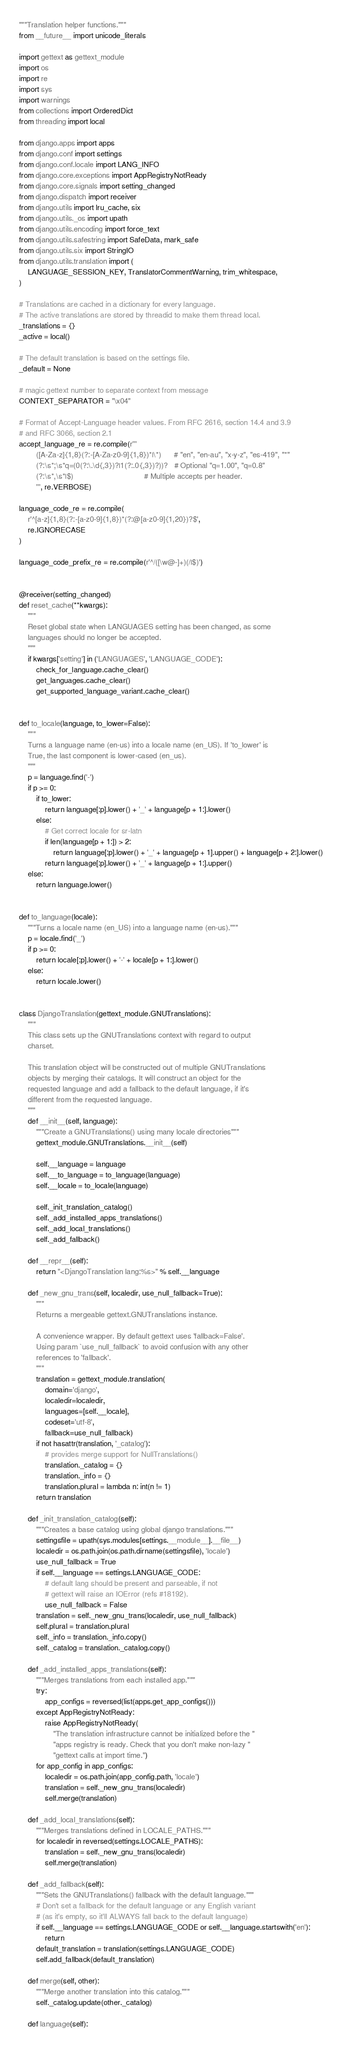Convert code to text. <code><loc_0><loc_0><loc_500><loc_500><_Python_>"""Translation helper functions."""
from __future__ import unicode_literals

import gettext as gettext_module
import os
import re
import sys
import warnings
from collections import OrderedDict
from threading import local

from django.apps import apps
from django.conf import settings
from django.conf.locale import LANG_INFO
from django.core.exceptions import AppRegistryNotReady
from django.core.signals import setting_changed
from django.dispatch import receiver
from django.utils import lru_cache, six
from django.utils._os import upath
from django.utils.encoding import force_text
from django.utils.safestring import SafeData, mark_safe
from django.utils.six import StringIO
from django.utils.translation import (
    LANGUAGE_SESSION_KEY, TranslatorCommentWarning, trim_whitespace,
)

# Translations are cached in a dictionary for every language.
# The active translations are stored by threadid to make them thread local.
_translations = {}
_active = local()

# The default translation is based on the settings file.
_default = None

# magic gettext number to separate context from message
CONTEXT_SEPARATOR = "\x04"

# Format of Accept-Language header values. From RFC 2616, section 14.4 and 3.9
# and RFC 3066, section 2.1
accept_language_re = re.compile(r'''
        ([A-Za-z]{1,8}(?:-[A-Za-z0-9]{1,8})*|\*)      # "en", "en-au", "x-y-z", "es-419", "*"
        (?:\s*;\s*q=(0(?:\.\d{,3})?|1(?:.0{,3})?))?   # Optional "q=1.00", "q=0.8"
        (?:\s*,\s*|$)                                 # Multiple accepts per header.
        ''', re.VERBOSE)

language_code_re = re.compile(
    r'^[a-z]{1,8}(?:-[a-z0-9]{1,8})*(?:@[a-z0-9]{1,20})?$',
    re.IGNORECASE
)

language_code_prefix_re = re.compile(r'^/([\w@-]+)(/|$)')


@receiver(setting_changed)
def reset_cache(**kwargs):
    """
    Reset global state when LANGUAGES setting has been changed, as some
    languages should no longer be accepted.
    """
    if kwargs['setting'] in ('LANGUAGES', 'LANGUAGE_CODE'):
        check_for_language.cache_clear()
        get_languages.cache_clear()
        get_supported_language_variant.cache_clear()


def to_locale(language, to_lower=False):
    """
    Turns a language name (en-us) into a locale name (en_US). If 'to_lower' is
    True, the last component is lower-cased (en_us).
    """
    p = language.find('-')
    if p >= 0:
        if to_lower:
            return language[:p].lower() + '_' + language[p + 1:].lower()
        else:
            # Get correct locale for sr-latn
            if len(language[p + 1:]) > 2:
                return language[:p].lower() + '_' + language[p + 1].upper() + language[p + 2:].lower()
            return language[:p].lower() + '_' + language[p + 1:].upper()
    else:
        return language.lower()


def to_language(locale):
    """Turns a locale name (en_US) into a language name (en-us)."""
    p = locale.find('_')
    if p >= 0:
        return locale[:p].lower() + '-' + locale[p + 1:].lower()
    else:
        return locale.lower()


class DjangoTranslation(gettext_module.GNUTranslations):
    """
    This class sets up the GNUTranslations context with regard to output
    charset.

    This translation object will be constructed out of multiple GNUTranslations
    objects by merging their catalogs. It will construct an object for the
    requested language and add a fallback to the default language, if it's
    different from the requested language.
    """
    def __init__(self, language):
        """Create a GNUTranslations() using many locale directories"""
        gettext_module.GNUTranslations.__init__(self)

        self.__language = language
        self.__to_language = to_language(language)
        self.__locale = to_locale(language)

        self._init_translation_catalog()
        self._add_installed_apps_translations()
        self._add_local_translations()
        self._add_fallback()

    def __repr__(self):
        return "<DjangoTranslation lang:%s>" % self.__language

    def _new_gnu_trans(self, localedir, use_null_fallback=True):
        """
        Returns a mergeable gettext.GNUTranslations instance.

        A convenience wrapper. By default gettext uses 'fallback=False'.
        Using param `use_null_fallback` to avoid confusion with any other
        references to 'fallback'.
        """
        translation = gettext_module.translation(
            domain='django',
            localedir=localedir,
            languages=[self.__locale],
            codeset='utf-8',
            fallback=use_null_fallback)
        if not hasattr(translation, '_catalog'):
            # provides merge support for NullTranslations()
            translation._catalog = {}
            translation._info = {}
            translation.plural = lambda n: int(n != 1)
        return translation

    def _init_translation_catalog(self):
        """Creates a base catalog using global django translations."""
        settingsfile = upath(sys.modules[settings.__module__].__file__)
        localedir = os.path.join(os.path.dirname(settingsfile), 'locale')
        use_null_fallback = True
        if self.__language == settings.LANGUAGE_CODE:
            # default lang should be present and parseable, if not
            # gettext will raise an IOError (refs #18192).
            use_null_fallback = False
        translation = self._new_gnu_trans(localedir, use_null_fallback)
        self.plural = translation.plural
        self._info = translation._info.copy()
        self._catalog = translation._catalog.copy()

    def _add_installed_apps_translations(self):
        """Merges translations from each installed app."""
        try:
            app_configs = reversed(list(apps.get_app_configs()))
        except AppRegistryNotReady:
            raise AppRegistryNotReady(
                "The translation infrastructure cannot be initialized before the "
                "apps registry is ready. Check that you don't make non-lazy "
                "gettext calls at import time.")
        for app_config in app_configs:
            localedir = os.path.join(app_config.path, 'locale')
            translation = self._new_gnu_trans(localedir)
            self.merge(translation)

    def _add_local_translations(self):
        """Merges translations defined in LOCALE_PATHS."""
        for localedir in reversed(settings.LOCALE_PATHS):
            translation = self._new_gnu_trans(localedir)
            self.merge(translation)

    def _add_fallback(self):
        """Sets the GNUTranslations() fallback with the default language."""
        # Don't set a fallback for the default language or any English variant
        # (as it's empty, so it'll ALWAYS fall back to the default language)
        if self.__language == settings.LANGUAGE_CODE or self.__language.startswith('en'):
            return
        default_translation = translation(settings.LANGUAGE_CODE)
        self.add_fallback(default_translation)

    def merge(self, other):
        """Merge another translation into this catalog."""
        self._catalog.update(other._catalog)

    def language(self):</code> 